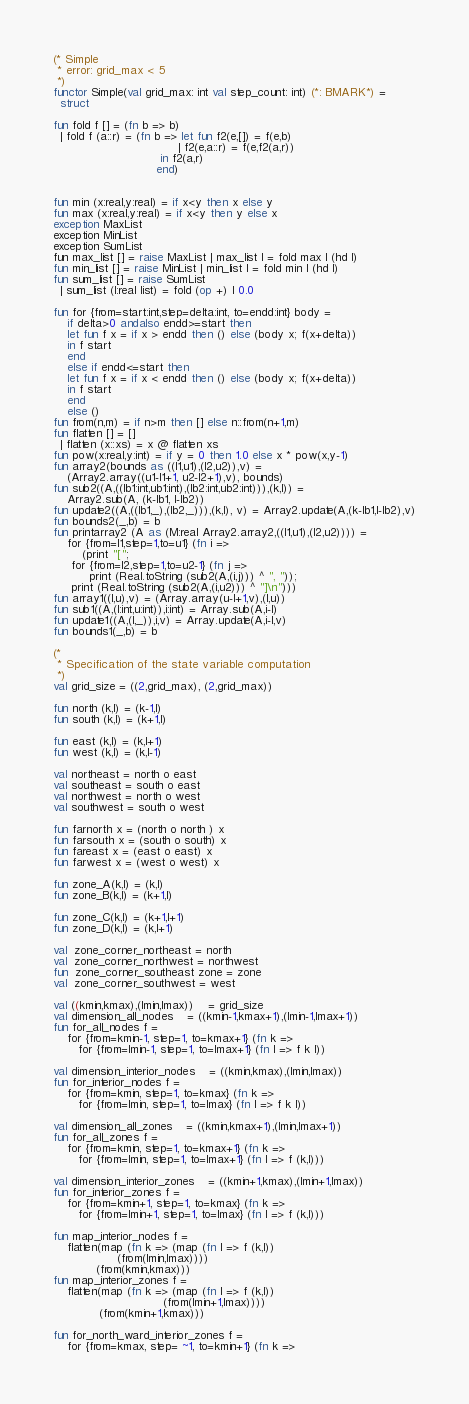Convert code to text. <code><loc_0><loc_0><loc_500><loc_500><_SML_>(* Simple
 * error: grid_max < 5
 *)
functor Simple(val grid_max: int val step_count: int) (*: BMARK*) =
  struct

fun fold f [] = (fn b => b)
  | fold f (a::r) = (fn b => let fun f2(e,[]) = f(e,b)
                                   | f2(e,a::r) = f(e,f2(a,r))
                              in f2(a,r)
                             end)


fun min (x:real,y:real) = if x<y then x else y
fun max (x:real,y:real) = if x<y then y else x
exception MaxList
exception MinList
exception SumList
fun max_list [] = raise MaxList | max_list l = fold max l (hd l)
fun min_list [] = raise MinList | min_list l = fold min l (hd l)
fun sum_list [] = raise SumList
  | sum_list (l:real list) = fold (op +) l 0.0

fun for {from=start:int,step=delta:int, to=endd:int} body =
    if delta>0 andalso endd>=start then 
	let fun f x = if x > endd then () else (body x; f(x+delta))
	in f start
	end
    else if endd<=start then
	let fun f x = if x < endd then () else (body x; f(x+delta))
	in f start
	end
    else ()
fun from(n,m) = if n>m then [] else n::from(n+1,m)
fun flatten [] = []
  | flatten (x::xs) = x @ flatten xs
fun pow(x:real,y:int) = if y = 0 then 1.0 else x * pow(x,y-1)
fun array2(bounds as ((l1,u1),(l2,u2)),v) =  
    (Array2.array((u1-l1+1, u2-l2+1),v), bounds)
fun sub2((A,((lb1:int,ub1:int),(lb2:int,ub2:int))),(k,l)) = 
    Array2.sub(A, (k-lb1, l-lb2)) 
fun update2((A,((lb1,_),(lb2,_))),(k,l), v) = Array2.update(A,(k-lb1,l-lb2),v)
fun bounds2(_,b) = b
fun printarray2 (A as (M:real Array2.array2,((l1,u1),(l2,u2)))) =
    for {from=l1,step=1,to=u1} (fn i =>
        (print "[";
	 for {from=l2,step=1,to=u2-1} (fn j => 
	      print (Real.toString (sub2(A,(i,j))) ^ ", "));
	 print (Real.toString (sub2(A,(i,u2))) ^ "]\n")))
fun array1((l,u),v) = (Array.array(u-l+1,v),(l,u))
fun sub1((A,(l:int,u:int)),i:int) = Array.sub(A,i-l) 
fun update1((A,(l,_)),i,v) = Array.update(A,i-l,v)
fun bounds1(_,b) = b

(*
 * Specification of the state variable computation
 *)
val grid_size = ((2,grid_max), (2,grid_max))

fun north (k,l) = (k-1,l)	
fun south (k,l) = (k+1,l)		

fun east (k,l) = (k,l+1)
fun west (k,l) = (k,l-1)

val northeast = north o east
val southeast = south o east
val northwest = north o west		
val southwest = south o west

fun farnorth x = (north o north ) x
fun farsouth x = (south o south) x
fun fareast x = (east o east) x
fun farwest x = (west o west) x

fun zone_A(k,l) = (k,l)
fun zone_B(k,l) = (k+1,l)

fun zone_C(k,l) = (k+1,l+1)		
fun zone_D(k,l) = (k,l+1)

val  zone_corner_northeast = north   
val  zone_corner_northwest = northwest
fun  zone_corner_southeast zone = zone
val  zone_corner_southwest = west

val ((kmin,kmax),(lmin,lmax)) 	= grid_size
val dimension_all_nodes   	= ((kmin-1,kmax+1),(lmin-1,lmax+1))
fun for_all_nodes f =
    for {from=kmin-1, step=1, to=kmax+1} (fn k =>
       for {from=lmin-1, step=1, to=lmax+1} (fn l => f k l))

val dimension_interior_nodes  	= ((kmin,kmax),(lmin,lmax))
fun for_interior_nodes f =
    for {from=kmin, step=1, to=kmax} (fn k =>
       for {from=lmin, step=1, to=lmax} (fn l => f k l))

val dimension_all_zones  	= ((kmin,kmax+1),(lmin,lmax+1))
fun for_all_zones f =
    for {from=kmin, step=1, to=kmax+1} (fn k =>
       for {from=lmin, step=1, to=lmax+1} (fn l => f (k,l)))

val dimension_interior_zones  	= ((kmin+1,kmax),(lmin+1,lmax))
fun for_interior_zones f =
    for {from=kmin+1, step=1, to=kmax} (fn k =>
       for {from=lmin+1, step=1, to=lmax} (fn l => f (k,l)))

fun map_interior_nodes f =
    flatten(map (fn k => (map (fn l => f (k,l)) 
			      (from(lmin,lmax))))
	        (from(kmin,kmax)))
fun map_interior_zones f =
    flatten(map (fn k => (map (fn l => f (k,l)) 
                               (from(lmin+1,lmax))))
	         (from(kmin+1,kmax)))

fun for_north_ward_interior_zones f =
    for {from=kmax, step= ~1, to=kmin+1} (fn k =></code> 